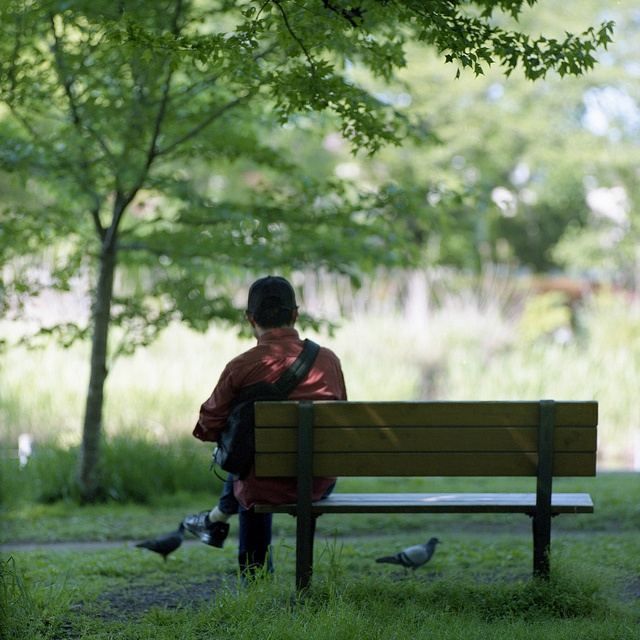Describe the objects in this image and their specific colors. I can see bench in teal, black, green, lightblue, and darkgreen tones, people in teal, black, maroon, gray, and purple tones, backpack in teal, black, darkblue, and blue tones, bird in teal, black, blue, and darkblue tones, and bird in teal, black, blue, and darkblue tones in this image. 